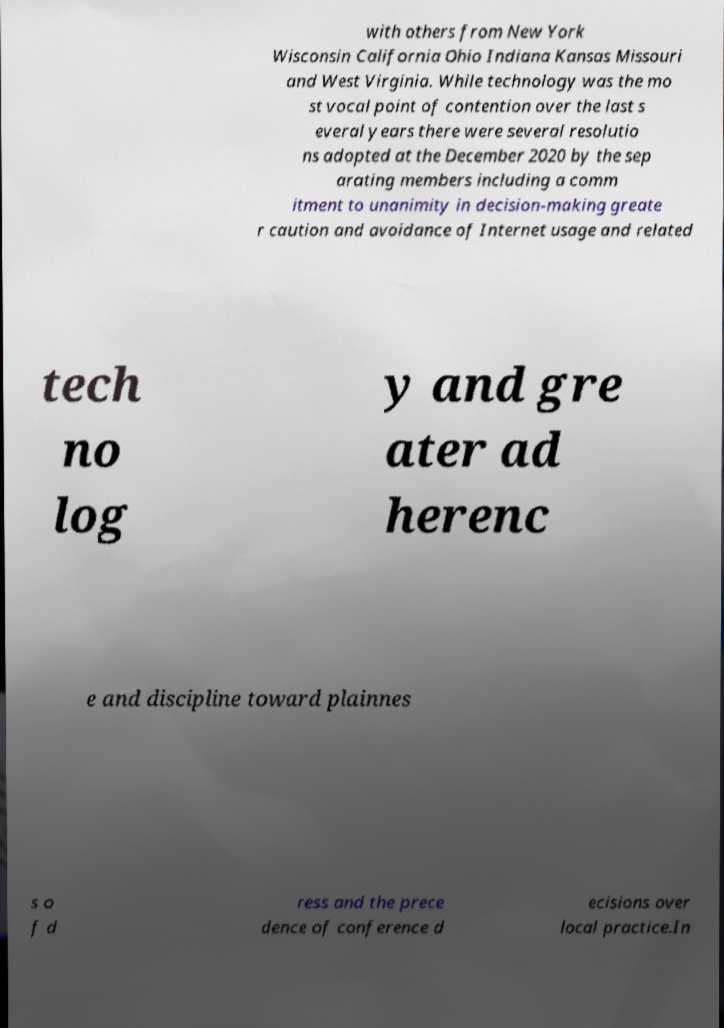Please identify and transcribe the text found in this image. with others from New York Wisconsin California Ohio Indiana Kansas Missouri and West Virginia. While technology was the mo st vocal point of contention over the last s everal years there were several resolutio ns adopted at the December 2020 by the sep arating members including a comm itment to unanimity in decision-making greate r caution and avoidance of Internet usage and related tech no log y and gre ater ad herenc e and discipline toward plainnes s o f d ress and the prece dence of conference d ecisions over local practice.In 